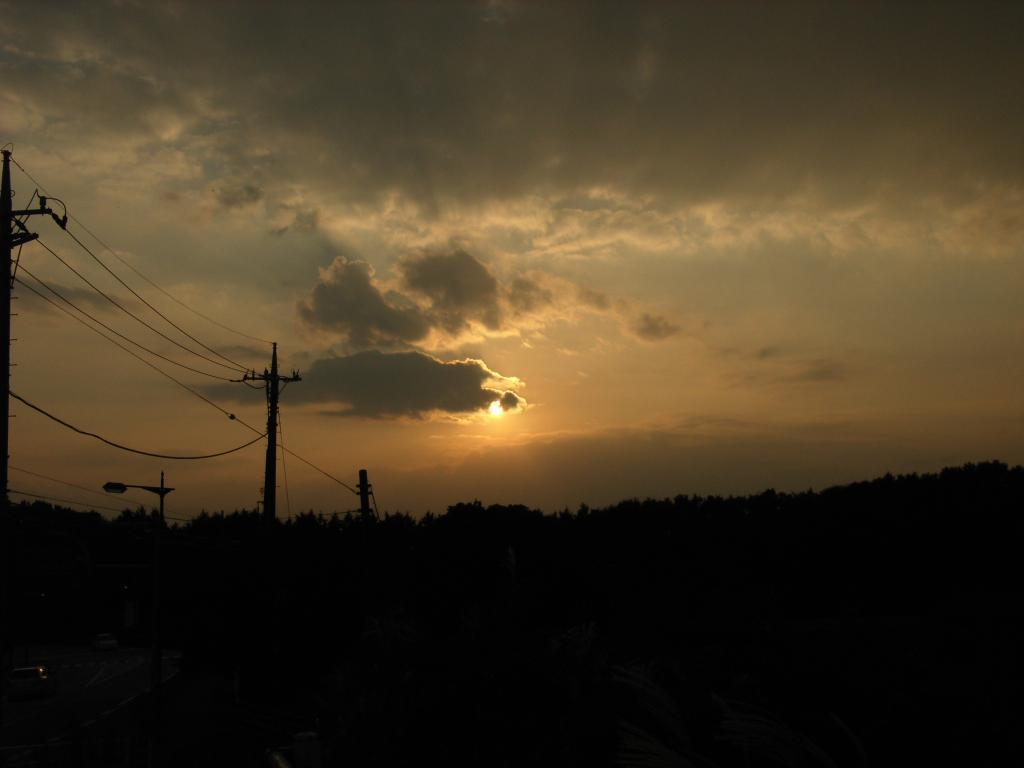What structures can be seen on the left side of the image? There are electric poles on the left side of the image. What is located behind the electric poles? There are trees behind the electric poles. What is visible in the sky in the image? The sky is visible in the image, and clouds and the sun are present. What type of milk can be seen being poured in the image? There is no milk present in the image; it features electric poles, trees, and a sky with clouds and the sun. 